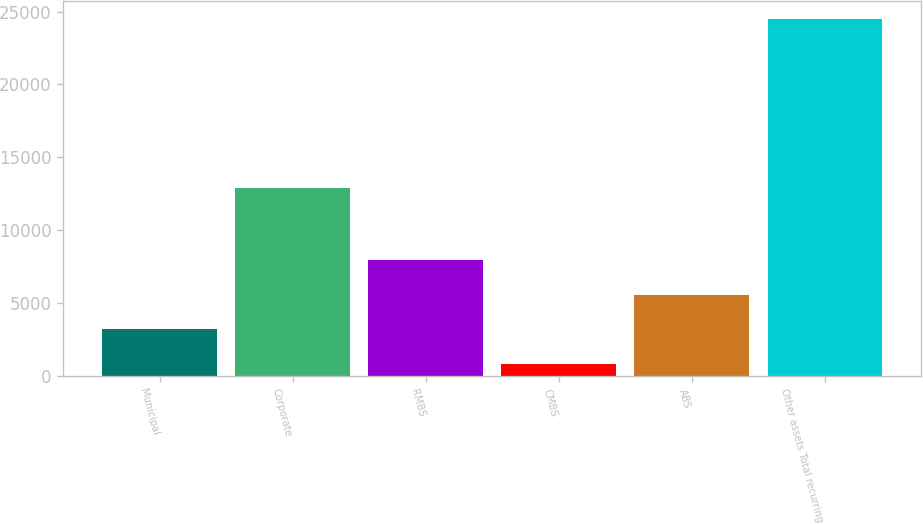<chart> <loc_0><loc_0><loc_500><loc_500><bar_chart><fcel>Municipal<fcel>Corporate<fcel>RMBS<fcel>CMBS<fcel>ABS<fcel>Other assets Total recurring<nl><fcel>3201<fcel>12868<fcel>7937<fcel>833<fcel>5569<fcel>24513<nl></chart> 